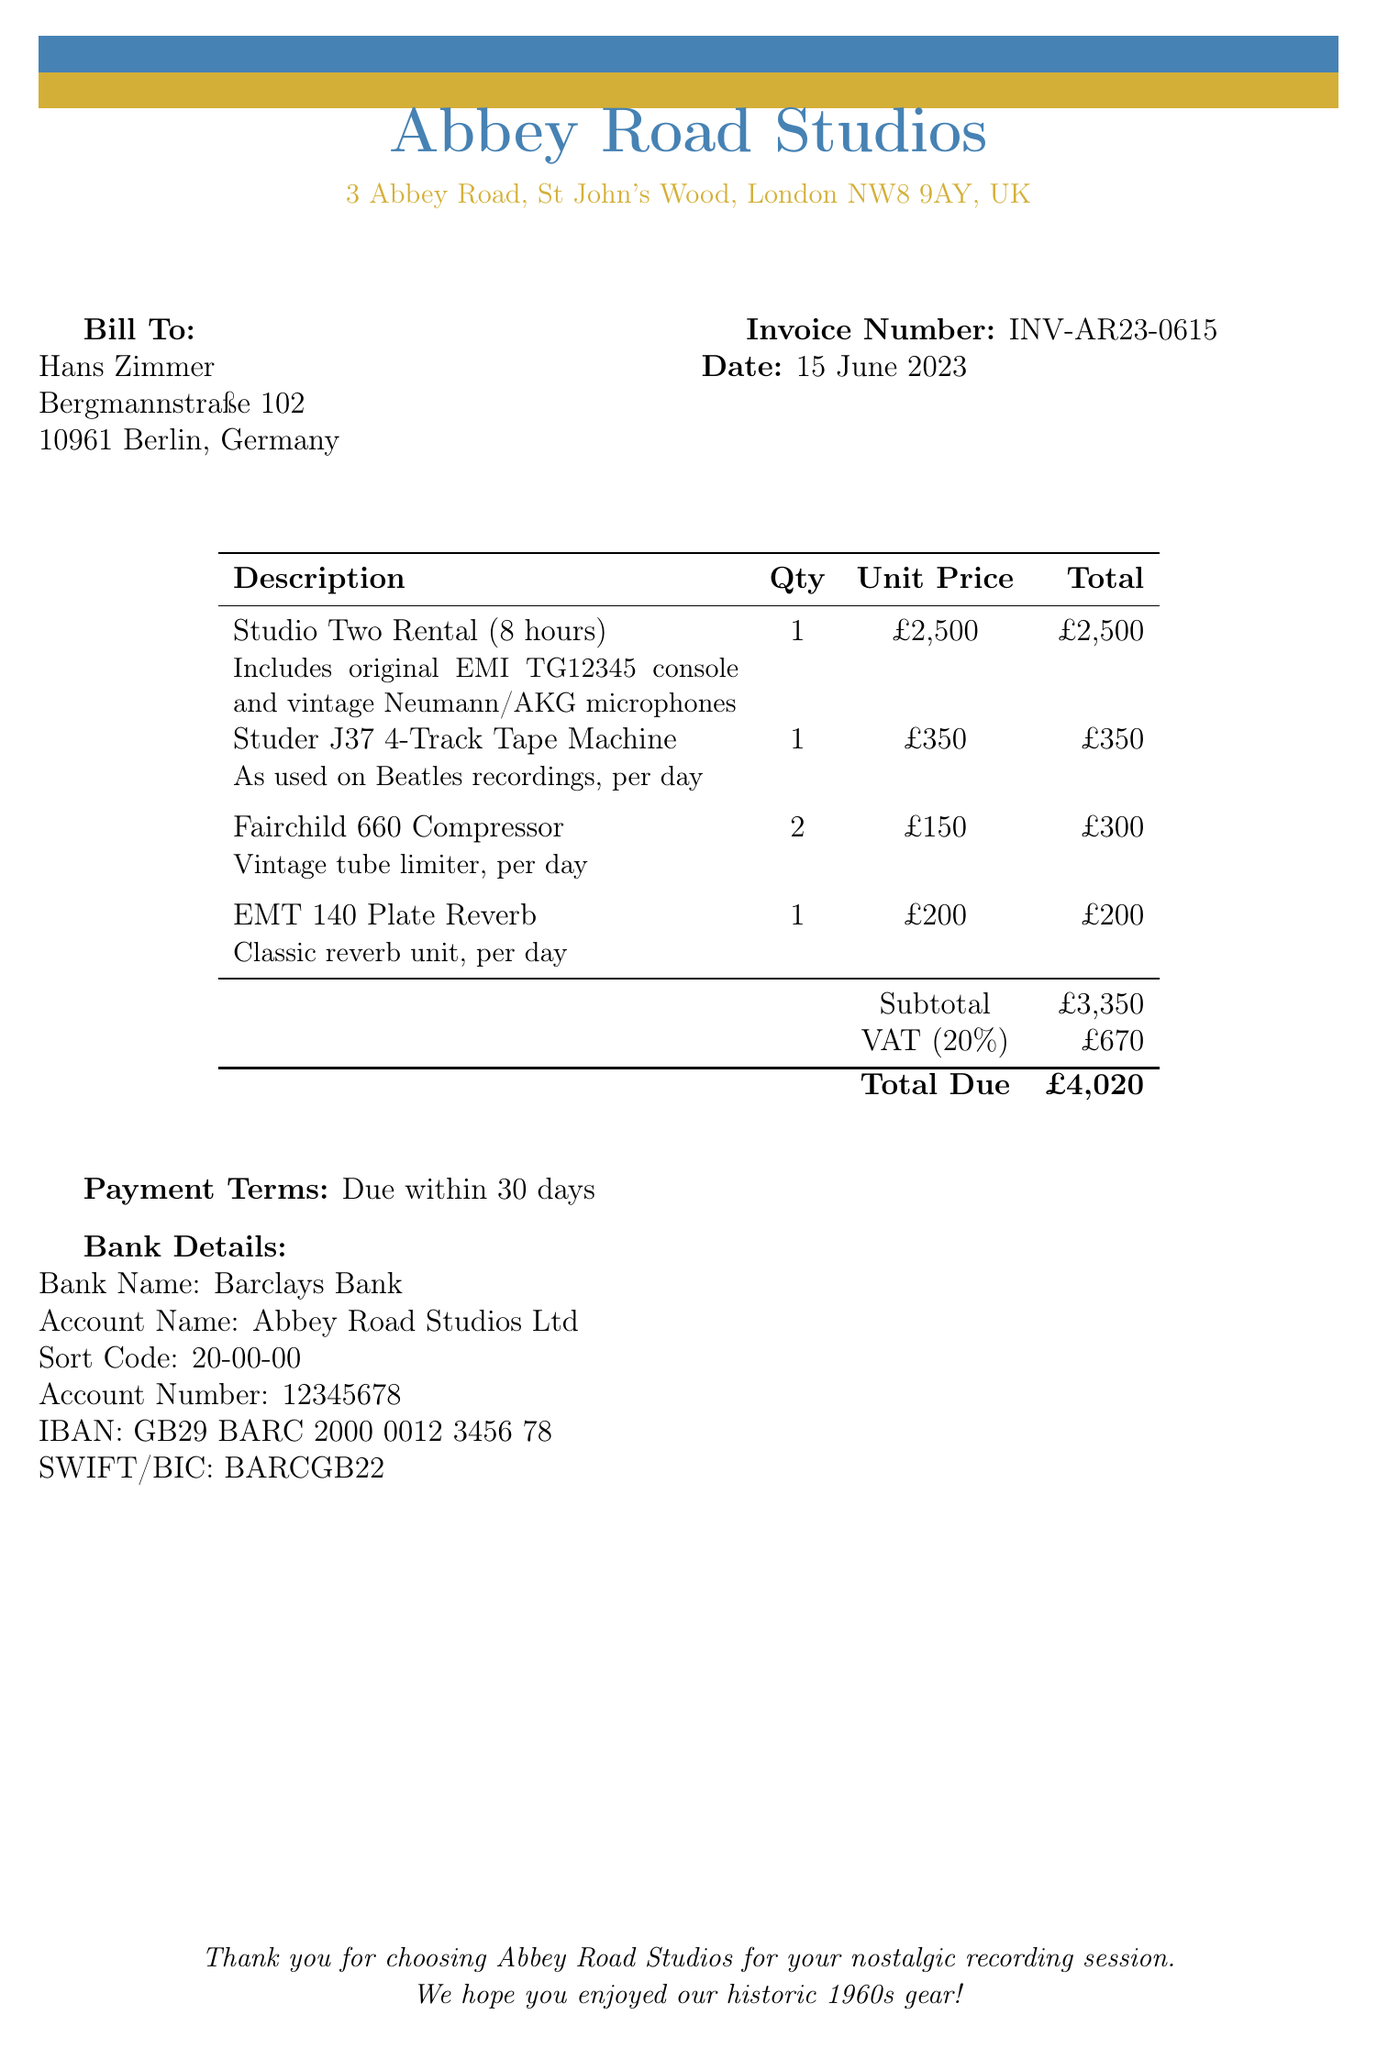what is the invoice number? The invoice number is specified in the document under the invoice details.
Answer: INV-AR23-0615 what is the date of the invoice? The date of the invoice is provided together with the invoice number in the document.
Answer: 15 June 2023 how much does the Studio Two rental cost? The cost of renting Studio Two is listed in the description of the services provided.
Answer: £2,500 what is the total amount due? The total due is located at the bottom of the invoice, summing up all charges including VAT.
Answer: £4,020 how many Fairchild 660 Compressors are included in the invoice? The quantity for the Fairchild 660 Compressors is stated in the itemized list of charges.
Answer: 2 what is the VAT percentage applied? The VAT percentage is specified in the invoice under the relevant charges section.
Answer: 20% which vintage tape machine is mentioned in the invoice? The type of vintage tape machine is detailed in the list of items provided in the document.
Answer: Studer J37 4-Track Tape Machine how many hours is the Studio Two rental for? The duration of the Studio Two rental is indicated in the description of the rental service.
Answer: 8 hours what is the payment term stated in the invoice? The payment terms are stated clearly in the document regarding when payment is due.
Answer: Due within 30 days 